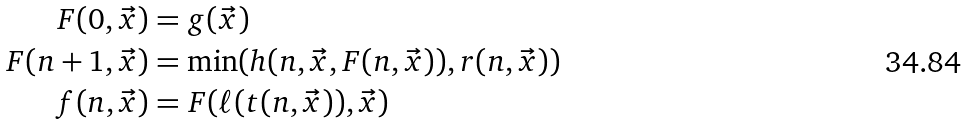<formula> <loc_0><loc_0><loc_500><loc_500>F ( 0 , \vec { x } ) & = g ( \vec { x } ) \\ F ( n + 1 , \vec { x } ) & = \min ( h ( n , \vec { x } , F ( n , \vec { x } ) ) , r ( n , \vec { x } ) ) \\ f ( n , \vec { x } ) & = F ( \ell ( t ( n , \vec { x } ) ) , \vec { x } )</formula> 